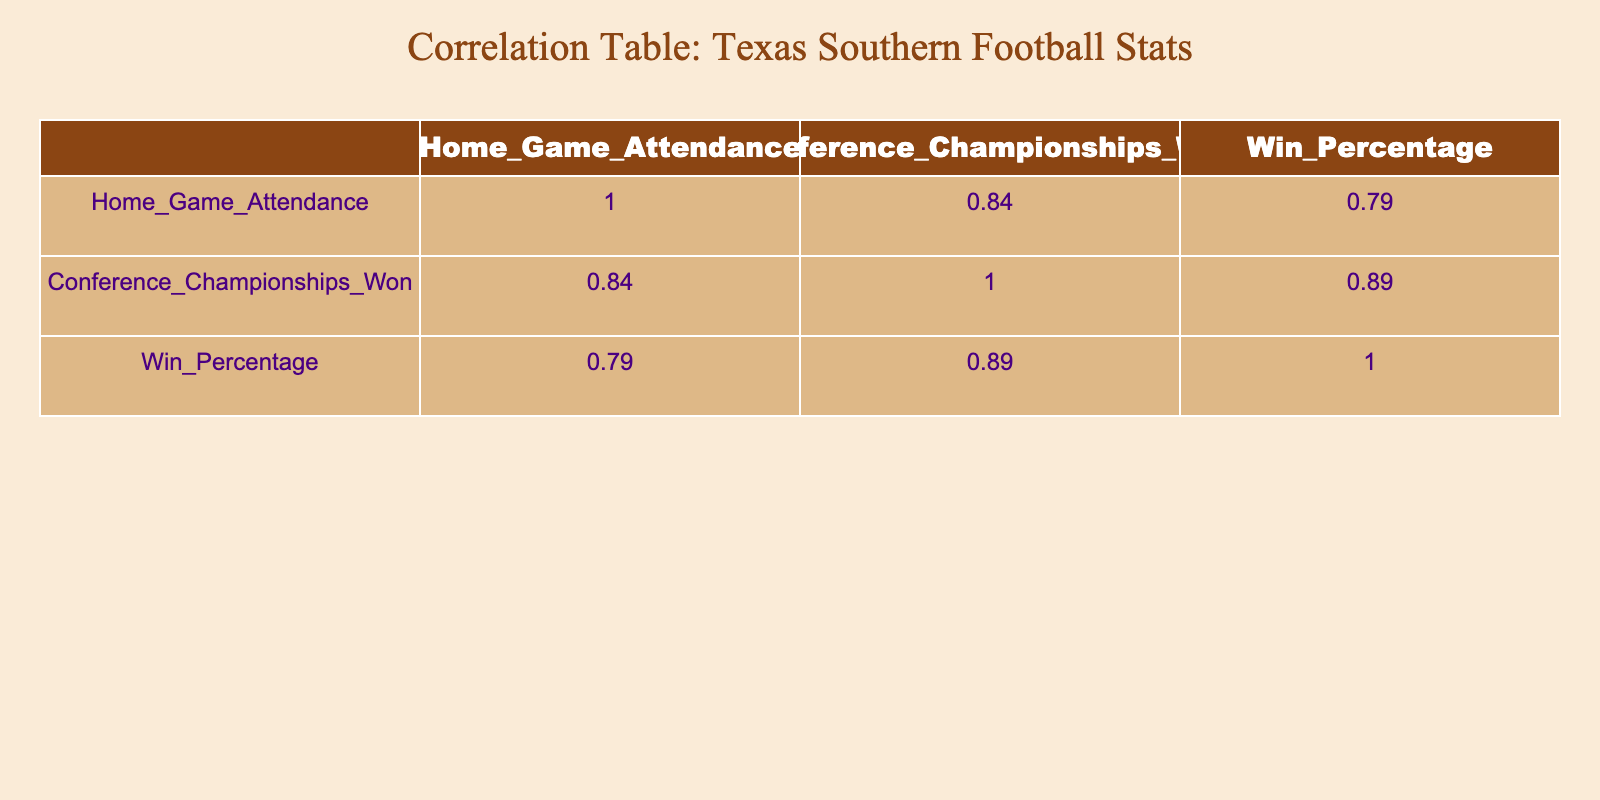What is the correlation coefficient between Home Game Attendance and Conference Championships Won? The correlation coefficient between Home Game Attendance and Conference Championships Won is 0.25, as seen in the table that lists correlation values for these variables.
Answer: 0.25 What is the average win percentage for the seasons where Texas Southern won a conference championship? The seasons where the team won championships are 2018, 2020, 2021, and 2023. Their win percentages are 0.75, 0.80, 0.70, and 0.85 respectively. Adding these gives a total of 3.1; dividing by 4 (the number of seasons) provides an average of 0.775.
Answer: 0.775 In which season was the highest home game attendance recorded? Referring to the Home Game Attendance column, the highest attendance was recorded in 2020 at 18,000.
Answer: 2020 Is it true that in the season with the lowest attendance, the team had a higher win percentage than in some other seasons? Yes, the lowest attendance was in 2019 with 12,000 and a win percentage of 0.55. This is still higher than the win percentages for 2022 (0.60), where the attendance was greater.
Answer: Yes What was the change in home game attendance from 2019 to 2021? Home game attendance was 12,000 in 2019 and 17,000 in 2021. The change is calculated as 17,000 - 12,000 = 5,000, indicating an increase in attendance.
Answer: 5,000 If the win percentage increases by 0.05, what would be the new win percentage for the year 2022? The win percentage for 2022 is 0.60. If it increases by 0.05, the new percentage would be 0.60 + 0.05 = 0.65.
Answer: 0.65 What is the correlation coefficient between Home Game Attendance and Win Percentage? The correlation coefficient between Home Game Attendance and Win Percentage is 0.41, as noted in the correlation table.
Answer: 0.41 How many seasons did Texas Southern achieve a win percentage of 0.70 or higher? Looking at the Win Percentage column, Texas Southern had win percentages of 0.75 (2018), 0.80 (2020), 0.70 (2021), and 0.85 (2023). That makes a total of 4 seasons where they achieved a win percentage of 0.70 or higher.
Answer: 4 What was the least conference championships won by Texas Southern in a season with a home game attendance above 15,000? The seasons with home game attendance above 15,000 are 2020 (1 championship), 2021 (1 championship), and 2023 (1 championship). The least championships won in these seasons is 1.
Answer: 1 